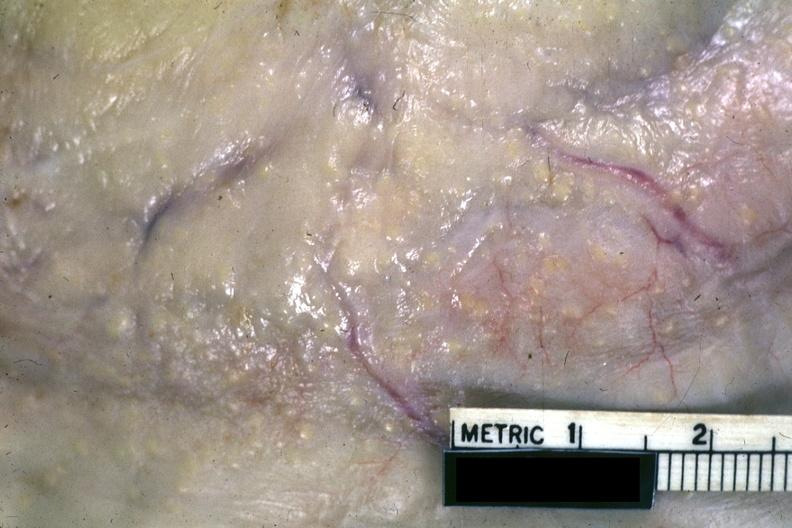s abdomen present?
Answer the question using a single word or phrase. Yes 